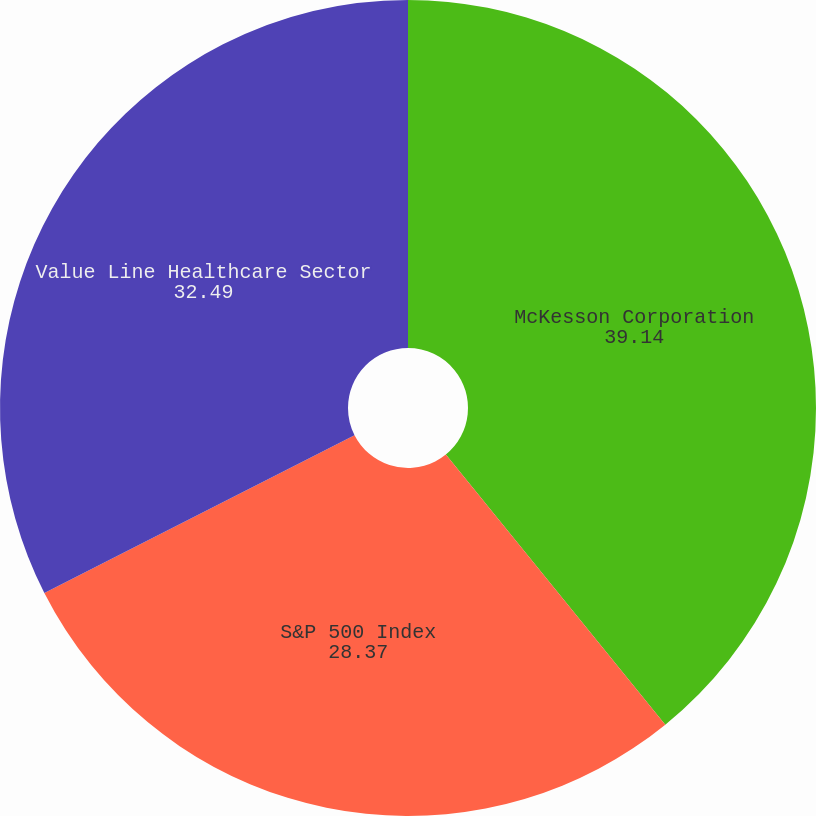<chart> <loc_0><loc_0><loc_500><loc_500><pie_chart><fcel>McKesson Corporation<fcel>S&P 500 Index<fcel>Value Line Healthcare Sector<nl><fcel>39.14%<fcel>28.37%<fcel>32.49%<nl></chart> 